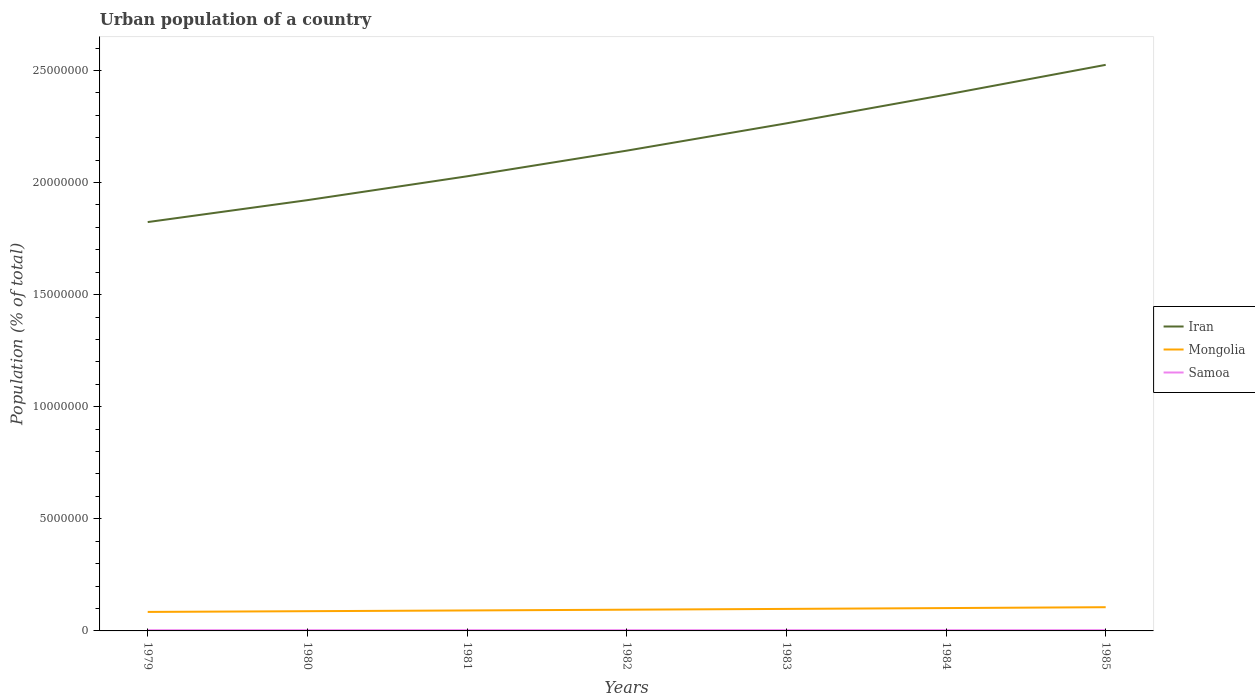How many different coloured lines are there?
Offer a terse response. 3. Across all years, what is the maximum urban population in Samoa?
Your response must be concise. 3.27e+04. In which year was the urban population in Iran maximum?
Offer a terse response. 1979. What is the total urban population in Samoa in the graph?
Your response must be concise. -632. What is the difference between the highest and the second highest urban population in Samoa?
Offer a very short reply. 1189. What is the difference between the highest and the lowest urban population in Samoa?
Keep it short and to the point. 4. Is the urban population in Samoa strictly greater than the urban population in Iran over the years?
Your answer should be compact. Yes. How many lines are there?
Ensure brevity in your answer.  3. How many years are there in the graph?
Give a very brief answer. 7. What is the difference between two consecutive major ticks on the Y-axis?
Keep it short and to the point. 5.00e+06. Does the graph contain any zero values?
Offer a terse response. No. How are the legend labels stacked?
Your answer should be compact. Vertical. What is the title of the graph?
Keep it short and to the point. Urban population of a country. Does "Aruba" appear as one of the legend labels in the graph?
Give a very brief answer. No. What is the label or title of the X-axis?
Provide a short and direct response. Years. What is the label or title of the Y-axis?
Provide a succinct answer. Population (% of total). What is the Population (% of total) in Iran in 1979?
Give a very brief answer. 1.82e+07. What is the Population (% of total) of Mongolia in 1979?
Make the answer very short. 8.48e+05. What is the Population (% of total) in Samoa in 1979?
Offer a very short reply. 3.27e+04. What is the Population (% of total) of Iran in 1980?
Ensure brevity in your answer.  1.92e+07. What is the Population (% of total) in Mongolia in 1980?
Your response must be concise. 8.80e+05. What is the Population (% of total) of Samoa in 1980?
Provide a short and direct response. 3.29e+04. What is the Population (% of total) of Iran in 1981?
Your answer should be compact. 2.03e+07. What is the Population (% of total) of Mongolia in 1981?
Your response must be concise. 9.13e+05. What is the Population (% of total) in Samoa in 1981?
Your answer should be compact. 3.32e+04. What is the Population (% of total) of Iran in 1982?
Ensure brevity in your answer.  2.14e+07. What is the Population (% of total) in Mongolia in 1982?
Provide a succinct answer. 9.47e+05. What is the Population (% of total) of Samoa in 1982?
Ensure brevity in your answer.  3.34e+04. What is the Population (% of total) of Iran in 1983?
Your answer should be very brief. 2.26e+07. What is the Population (% of total) of Mongolia in 1983?
Offer a terse response. 9.82e+05. What is the Population (% of total) of Samoa in 1983?
Your answer should be very brief. 3.36e+04. What is the Population (% of total) in Iran in 1984?
Give a very brief answer. 2.39e+07. What is the Population (% of total) of Mongolia in 1984?
Keep it short and to the point. 1.02e+06. What is the Population (% of total) of Samoa in 1984?
Your answer should be very brief. 3.38e+04. What is the Population (% of total) of Iran in 1985?
Your response must be concise. 2.53e+07. What is the Population (% of total) of Mongolia in 1985?
Give a very brief answer. 1.06e+06. What is the Population (% of total) in Samoa in 1985?
Your answer should be very brief. 3.39e+04. Across all years, what is the maximum Population (% of total) in Iran?
Offer a very short reply. 2.53e+07. Across all years, what is the maximum Population (% of total) of Mongolia?
Provide a succinct answer. 1.06e+06. Across all years, what is the maximum Population (% of total) in Samoa?
Ensure brevity in your answer.  3.39e+04. Across all years, what is the minimum Population (% of total) of Iran?
Offer a very short reply. 1.82e+07. Across all years, what is the minimum Population (% of total) of Mongolia?
Offer a very short reply. 8.48e+05. Across all years, what is the minimum Population (% of total) of Samoa?
Provide a succinct answer. 3.27e+04. What is the total Population (% of total) of Iran in the graph?
Ensure brevity in your answer.  1.51e+08. What is the total Population (% of total) of Mongolia in the graph?
Your answer should be very brief. 6.65e+06. What is the total Population (% of total) in Samoa in the graph?
Provide a short and direct response. 2.33e+05. What is the difference between the Population (% of total) in Iran in 1979 and that in 1980?
Make the answer very short. -9.78e+05. What is the difference between the Population (% of total) of Mongolia in 1979 and that in 1980?
Provide a succinct answer. -3.24e+04. What is the difference between the Population (% of total) in Samoa in 1979 and that in 1980?
Your response must be concise. -198. What is the difference between the Population (% of total) of Iran in 1979 and that in 1981?
Make the answer very short. -2.04e+06. What is the difference between the Population (% of total) of Mongolia in 1979 and that in 1981?
Offer a very short reply. -6.55e+04. What is the difference between the Population (% of total) of Samoa in 1979 and that in 1981?
Provide a succinct answer. -416. What is the difference between the Population (% of total) of Iran in 1979 and that in 1982?
Give a very brief answer. -3.19e+06. What is the difference between the Population (% of total) of Mongolia in 1979 and that in 1982?
Offer a very short reply. -9.93e+04. What is the difference between the Population (% of total) of Samoa in 1979 and that in 1982?
Your answer should be very brief. -632. What is the difference between the Population (% of total) of Iran in 1979 and that in 1983?
Provide a succinct answer. -4.40e+06. What is the difference between the Population (% of total) in Mongolia in 1979 and that in 1983?
Provide a succinct answer. -1.34e+05. What is the difference between the Population (% of total) of Samoa in 1979 and that in 1983?
Your answer should be very brief. -840. What is the difference between the Population (% of total) in Iran in 1979 and that in 1984?
Give a very brief answer. -5.68e+06. What is the difference between the Population (% of total) in Mongolia in 1979 and that in 1984?
Provide a succinct answer. -1.71e+05. What is the difference between the Population (% of total) in Samoa in 1979 and that in 1984?
Offer a very short reply. -1031. What is the difference between the Population (% of total) in Iran in 1979 and that in 1985?
Your answer should be very brief. -7.01e+06. What is the difference between the Population (% of total) in Mongolia in 1979 and that in 1985?
Offer a very short reply. -2.10e+05. What is the difference between the Population (% of total) of Samoa in 1979 and that in 1985?
Provide a short and direct response. -1189. What is the difference between the Population (% of total) of Iran in 1980 and that in 1981?
Offer a very short reply. -1.06e+06. What is the difference between the Population (% of total) of Mongolia in 1980 and that in 1981?
Make the answer very short. -3.31e+04. What is the difference between the Population (% of total) in Samoa in 1980 and that in 1981?
Make the answer very short. -218. What is the difference between the Population (% of total) of Iran in 1980 and that in 1982?
Provide a short and direct response. -2.21e+06. What is the difference between the Population (% of total) in Mongolia in 1980 and that in 1982?
Provide a short and direct response. -6.70e+04. What is the difference between the Population (% of total) of Samoa in 1980 and that in 1982?
Provide a succinct answer. -434. What is the difference between the Population (% of total) in Iran in 1980 and that in 1983?
Offer a terse response. -3.43e+06. What is the difference between the Population (% of total) in Mongolia in 1980 and that in 1983?
Provide a succinct answer. -1.02e+05. What is the difference between the Population (% of total) in Samoa in 1980 and that in 1983?
Your response must be concise. -642. What is the difference between the Population (% of total) in Iran in 1980 and that in 1984?
Your answer should be compact. -4.71e+06. What is the difference between the Population (% of total) in Mongolia in 1980 and that in 1984?
Provide a short and direct response. -1.39e+05. What is the difference between the Population (% of total) of Samoa in 1980 and that in 1984?
Keep it short and to the point. -833. What is the difference between the Population (% of total) of Iran in 1980 and that in 1985?
Offer a terse response. -6.04e+06. What is the difference between the Population (% of total) in Mongolia in 1980 and that in 1985?
Your answer should be very brief. -1.78e+05. What is the difference between the Population (% of total) of Samoa in 1980 and that in 1985?
Your answer should be compact. -991. What is the difference between the Population (% of total) of Iran in 1981 and that in 1982?
Your answer should be compact. -1.14e+06. What is the difference between the Population (% of total) in Mongolia in 1981 and that in 1982?
Give a very brief answer. -3.38e+04. What is the difference between the Population (% of total) in Samoa in 1981 and that in 1982?
Give a very brief answer. -216. What is the difference between the Population (% of total) in Iran in 1981 and that in 1983?
Your response must be concise. -2.36e+06. What is the difference between the Population (% of total) in Mongolia in 1981 and that in 1983?
Your answer should be very brief. -6.89e+04. What is the difference between the Population (% of total) in Samoa in 1981 and that in 1983?
Make the answer very short. -424. What is the difference between the Population (% of total) in Iran in 1981 and that in 1984?
Ensure brevity in your answer.  -3.64e+06. What is the difference between the Population (% of total) of Mongolia in 1981 and that in 1984?
Give a very brief answer. -1.06e+05. What is the difference between the Population (% of total) of Samoa in 1981 and that in 1984?
Offer a very short reply. -615. What is the difference between the Population (% of total) in Iran in 1981 and that in 1985?
Your answer should be very brief. -4.97e+06. What is the difference between the Population (% of total) in Mongolia in 1981 and that in 1985?
Make the answer very short. -1.45e+05. What is the difference between the Population (% of total) in Samoa in 1981 and that in 1985?
Provide a short and direct response. -773. What is the difference between the Population (% of total) in Iran in 1982 and that in 1983?
Offer a very short reply. -1.22e+06. What is the difference between the Population (% of total) of Mongolia in 1982 and that in 1983?
Ensure brevity in your answer.  -3.50e+04. What is the difference between the Population (% of total) in Samoa in 1982 and that in 1983?
Your answer should be very brief. -208. What is the difference between the Population (% of total) in Iran in 1982 and that in 1984?
Your response must be concise. -2.50e+06. What is the difference between the Population (% of total) of Mongolia in 1982 and that in 1984?
Provide a short and direct response. -7.19e+04. What is the difference between the Population (% of total) of Samoa in 1982 and that in 1984?
Offer a terse response. -399. What is the difference between the Population (% of total) in Iran in 1982 and that in 1985?
Provide a short and direct response. -3.83e+06. What is the difference between the Population (% of total) in Mongolia in 1982 and that in 1985?
Offer a very short reply. -1.11e+05. What is the difference between the Population (% of total) in Samoa in 1982 and that in 1985?
Ensure brevity in your answer.  -557. What is the difference between the Population (% of total) of Iran in 1983 and that in 1984?
Your response must be concise. -1.28e+06. What is the difference between the Population (% of total) of Mongolia in 1983 and that in 1984?
Give a very brief answer. -3.69e+04. What is the difference between the Population (% of total) in Samoa in 1983 and that in 1984?
Ensure brevity in your answer.  -191. What is the difference between the Population (% of total) in Iran in 1983 and that in 1985?
Keep it short and to the point. -2.61e+06. What is the difference between the Population (% of total) in Mongolia in 1983 and that in 1985?
Ensure brevity in your answer.  -7.58e+04. What is the difference between the Population (% of total) of Samoa in 1983 and that in 1985?
Make the answer very short. -349. What is the difference between the Population (% of total) of Iran in 1984 and that in 1985?
Your answer should be very brief. -1.33e+06. What is the difference between the Population (% of total) in Mongolia in 1984 and that in 1985?
Provide a short and direct response. -3.90e+04. What is the difference between the Population (% of total) in Samoa in 1984 and that in 1985?
Make the answer very short. -158. What is the difference between the Population (% of total) of Iran in 1979 and the Population (% of total) of Mongolia in 1980?
Offer a very short reply. 1.74e+07. What is the difference between the Population (% of total) in Iran in 1979 and the Population (% of total) in Samoa in 1980?
Offer a terse response. 1.82e+07. What is the difference between the Population (% of total) in Mongolia in 1979 and the Population (% of total) in Samoa in 1980?
Provide a short and direct response. 8.15e+05. What is the difference between the Population (% of total) in Iran in 1979 and the Population (% of total) in Mongolia in 1981?
Your response must be concise. 1.73e+07. What is the difference between the Population (% of total) in Iran in 1979 and the Population (% of total) in Samoa in 1981?
Give a very brief answer. 1.82e+07. What is the difference between the Population (% of total) in Mongolia in 1979 and the Population (% of total) in Samoa in 1981?
Your answer should be compact. 8.14e+05. What is the difference between the Population (% of total) in Iran in 1979 and the Population (% of total) in Mongolia in 1982?
Provide a short and direct response. 1.73e+07. What is the difference between the Population (% of total) of Iran in 1979 and the Population (% of total) of Samoa in 1982?
Offer a terse response. 1.82e+07. What is the difference between the Population (% of total) of Mongolia in 1979 and the Population (% of total) of Samoa in 1982?
Make the answer very short. 8.14e+05. What is the difference between the Population (% of total) of Iran in 1979 and the Population (% of total) of Mongolia in 1983?
Provide a succinct answer. 1.73e+07. What is the difference between the Population (% of total) of Iran in 1979 and the Population (% of total) of Samoa in 1983?
Offer a very short reply. 1.82e+07. What is the difference between the Population (% of total) in Mongolia in 1979 and the Population (% of total) in Samoa in 1983?
Your response must be concise. 8.14e+05. What is the difference between the Population (% of total) in Iran in 1979 and the Population (% of total) in Mongolia in 1984?
Offer a very short reply. 1.72e+07. What is the difference between the Population (% of total) of Iran in 1979 and the Population (% of total) of Samoa in 1984?
Offer a very short reply. 1.82e+07. What is the difference between the Population (% of total) of Mongolia in 1979 and the Population (% of total) of Samoa in 1984?
Provide a succinct answer. 8.14e+05. What is the difference between the Population (% of total) of Iran in 1979 and the Population (% of total) of Mongolia in 1985?
Give a very brief answer. 1.72e+07. What is the difference between the Population (% of total) in Iran in 1979 and the Population (% of total) in Samoa in 1985?
Offer a very short reply. 1.82e+07. What is the difference between the Population (% of total) of Mongolia in 1979 and the Population (% of total) of Samoa in 1985?
Ensure brevity in your answer.  8.14e+05. What is the difference between the Population (% of total) in Iran in 1980 and the Population (% of total) in Mongolia in 1981?
Give a very brief answer. 1.83e+07. What is the difference between the Population (% of total) of Iran in 1980 and the Population (% of total) of Samoa in 1981?
Give a very brief answer. 1.92e+07. What is the difference between the Population (% of total) of Mongolia in 1980 and the Population (% of total) of Samoa in 1981?
Ensure brevity in your answer.  8.47e+05. What is the difference between the Population (% of total) of Iran in 1980 and the Population (% of total) of Mongolia in 1982?
Provide a succinct answer. 1.83e+07. What is the difference between the Population (% of total) in Iran in 1980 and the Population (% of total) in Samoa in 1982?
Give a very brief answer. 1.92e+07. What is the difference between the Population (% of total) in Mongolia in 1980 and the Population (% of total) in Samoa in 1982?
Keep it short and to the point. 8.47e+05. What is the difference between the Population (% of total) of Iran in 1980 and the Population (% of total) of Mongolia in 1983?
Your response must be concise. 1.82e+07. What is the difference between the Population (% of total) of Iran in 1980 and the Population (% of total) of Samoa in 1983?
Provide a short and direct response. 1.92e+07. What is the difference between the Population (% of total) of Mongolia in 1980 and the Population (% of total) of Samoa in 1983?
Your response must be concise. 8.46e+05. What is the difference between the Population (% of total) in Iran in 1980 and the Population (% of total) in Mongolia in 1984?
Your answer should be very brief. 1.82e+07. What is the difference between the Population (% of total) in Iran in 1980 and the Population (% of total) in Samoa in 1984?
Your response must be concise. 1.92e+07. What is the difference between the Population (% of total) in Mongolia in 1980 and the Population (% of total) in Samoa in 1984?
Your answer should be very brief. 8.46e+05. What is the difference between the Population (% of total) of Iran in 1980 and the Population (% of total) of Mongolia in 1985?
Make the answer very short. 1.82e+07. What is the difference between the Population (% of total) in Iran in 1980 and the Population (% of total) in Samoa in 1985?
Provide a short and direct response. 1.92e+07. What is the difference between the Population (% of total) in Mongolia in 1980 and the Population (% of total) in Samoa in 1985?
Give a very brief answer. 8.46e+05. What is the difference between the Population (% of total) of Iran in 1981 and the Population (% of total) of Mongolia in 1982?
Keep it short and to the point. 1.93e+07. What is the difference between the Population (% of total) of Iran in 1981 and the Population (% of total) of Samoa in 1982?
Offer a very short reply. 2.02e+07. What is the difference between the Population (% of total) in Mongolia in 1981 and the Population (% of total) in Samoa in 1982?
Your response must be concise. 8.80e+05. What is the difference between the Population (% of total) of Iran in 1981 and the Population (% of total) of Mongolia in 1983?
Keep it short and to the point. 1.93e+07. What is the difference between the Population (% of total) of Iran in 1981 and the Population (% of total) of Samoa in 1983?
Offer a very short reply. 2.02e+07. What is the difference between the Population (% of total) of Mongolia in 1981 and the Population (% of total) of Samoa in 1983?
Ensure brevity in your answer.  8.80e+05. What is the difference between the Population (% of total) of Iran in 1981 and the Population (% of total) of Mongolia in 1984?
Provide a succinct answer. 1.93e+07. What is the difference between the Population (% of total) of Iran in 1981 and the Population (% of total) of Samoa in 1984?
Keep it short and to the point. 2.02e+07. What is the difference between the Population (% of total) in Mongolia in 1981 and the Population (% of total) in Samoa in 1984?
Offer a very short reply. 8.79e+05. What is the difference between the Population (% of total) of Iran in 1981 and the Population (% of total) of Mongolia in 1985?
Your response must be concise. 1.92e+07. What is the difference between the Population (% of total) in Iran in 1981 and the Population (% of total) in Samoa in 1985?
Ensure brevity in your answer.  2.02e+07. What is the difference between the Population (% of total) in Mongolia in 1981 and the Population (% of total) in Samoa in 1985?
Your answer should be very brief. 8.79e+05. What is the difference between the Population (% of total) of Iran in 1982 and the Population (% of total) of Mongolia in 1983?
Keep it short and to the point. 2.04e+07. What is the difference between the Population (% of total) in Iran in 1982 and the Population (% of total) in Samoa in 1983?
Your answer should be compact. 2.14e+07. What is the difference between the Population (% of total) in Mongolia in 1982 and the Population (% of total) in Samoa in 1983?
Offer a very short reply. 9.13e+05. What is the difference between the Population (% of total) in Iran in 1982 and the Population (% of total) in Mongolia in 1984?
Offer a terse response. 2.04e+07. What is the difference between the Population (% of total) in Iran in 1982 and the Population (% of total) in Samoa in 1984?
Provide a short and direct response. 2.14e+07. What is the difference between the Population (% of total) in Mongolia in 1982 and the Population (% of total) in Samoa in 1984?
Offer a very short reply. 9.13e+05. What is the difference between the Population (% of total) of Iran in 1982 and the Population (% of total) of Mongolia in 1985?
Provide a short and direct response. 2.04e+07. What is the difference between the Population (% of total) of Iran in 1982 and the Population (% of total) of Samoa in 1985?
Offer a very short reply. 2.14e+07. What is the difference between the Population (% of total) in Mongolia in 1982 and the Population (% of total) in Samoa in 1985?
Provide a short and direct response. 9.13e+05. What is the difference between the Population (% of total) of Iran in 1983 and the Population (% of total) of Mongolia in 1984?
Offer a terse response. 2.16e+07. What is the difference between the Population (% of total) in Iran in 1983 and the Population (% of total) in Samoa in 1984?
Your answer should be very brief. 2.26e+07. What is the difference between the Population (% of total) in Mongolia in 1983 and the Population (% of total) in Samoa in 1984?
Provide a short and direct response. 9.48e+05. What is the difference between the Population (% of total) in Iran in 1983 and the Population (% of total) in Mongolia in 1985?
Offer a terse response. 2.16e+07. What is the difference between the Population (% of total) in Iran in 1983 and the Population (% of total) in Samoa in 1985?
Your answer should be very brief. 2.26e+07. What is the difference between the Population (% of total) of Mongolia in 1983 and the Population (% of total) of Samoa in 1985?
Your response must be concise. 9.48e+05. What is the difference between the Population (% of total) in Iran in 1984 and the Population (% of total) in Mongolia in 1985?
Give a very brief answer. 2.29e+07. What is the difference between the Population (% of total) in Iran in 1984 and the Population (% of total) in Samoa in 1985?
Give a very brief answer. 2.39e+07. What is the difference between the Population (% of total) of Mongolia in 1984 and the Population (% of total) of Samoa in 1985?
Offer a terse response. 9.85e+05. What is the average Population (% of total) of Iran per year?
Provide a short and direct response. 2.16e+07. What is the average Population (% of total) in Mongolia per year?
Offer a very short reply. 9.49e+05. What is the average Population (% of total) of Samoa per year?
Offer a terse response. 3.34e+04. In the year 1979, what is the difference between the Population (% of total) of Iran and Population (% of total) of Mongolia?
Offer a terse response. 1.74e+07. In the year 1979, what is the difference between the Population (% of total) of Iran and Population (% of total) of Samoa?
Make the answer very short. 1.82e+07. In the year 1979, what is the difference between the Population (% of total) of Mongolia and Population (% of total) of Samoa?
Keep it short and to the point. 8.15e+05. In the year 1980, what is the difference between the Population (% of total) of Iran and Population (% of total) of Mongolia?
Offer a terse response. 1.83e+07. In the year 1980, what is the difference between the Population (% of total) in Iran and Population (% of total) in Samoa?
Give a very brief answer. 1.92e+07. In the year 1980, what is the difference between the Population (% of total) of Mongolia and Population (% of total) of Samoa?
Your answer should be compact. 8.47e+05. In the year 1981, what is the difference between the Population (% of total) in Iran and Population (% of total) in Mongolia?
Your answer should be very brief. 1.94e+07. In the year 1981, what is the difference between the Population (% of total) in Iran and Population (% of total) in Samoa?
Provide a short and direct response. 2.02e+07. In the year 1981, what is the difference between the Population (% of total) of Mongolia and Population (% of total) of Samoa?
Give a very brief answer. 8.80e+05. In the year 1982, what is the difference between the Population (% of total) in Iran and Population (% of total) in Mongolia?
Your answer should be very brief. 2.05e+07. In the year 1982, what is the difference between the Population (% of total) of Iran and Population (% of total) of Samoa?
Make the answer very short. 2.14e+07. In the year 1982, what is the difference between the Population (% of total) in Mongolia and Population (% of total) in Samoa?
Give a very brief answer. 9.14e+05. In the year 1983, what is the difference between the Population (% of total) of Iran and Population (% of total) of Mongolia?
Provide a succinct answer. 2.17e+07. In the year 1983, what is the difference between the Population (% of total) of Iran and Population (% of total) of Samoa?
Provide a succinct answer. 2.26e+07. In the year 1983, what is the difference between the Population (% of total) in Mongolia and Population (% of total) in Samoa?
Ensure brevity in your answer.  9.48e+05. In the year 1984, what is the difference between the Population (% of total) of Iran and Population (% of total) of Mongolia?
Provide a succinct answer. 2.29e+07. In the year 1984, what is the difference between the Population (% of total) of Iran and Population (% of total) of Samoa?
Make the answer very short. 2.39e+07. In the year 1984, what is the difference between the Population (% of total) in Mongolia and Population (% of total) in Samoa?
Ensure brevity in your answer.  9.85e+05. In the year 1985, what is the difference between the Population (% of total) of Iran and Population (% of total) of Mongolia?
Offer a terse response. 2.42e+07. In the year 1985, what is the difference between the Population (% of total) of Iran and Population (% of total) of Samoa?
Ensure brevity in your answer.  2.52e+07. In the year 1985, what is the difference between the Population (% of total) of Mongolia and Population (% of total) of Samoa?
Offer a terse response. 1.02e+06. What is the ratio of the Population (% of total) of Iran in 1979 to that in 1980?
Make the answer very short. 0.95. What is the ratio of the Population (% of total) of Mongolia in 1979 to that in 1980?
Make the answer very short. 0.96. What is the ratio of the Population (% of total) in Iran in 1979 to that in 1981?
Offer a terse response. 0.9. What is the ratio of the Population (% of total) in Mongolia in 1979 to that in 1981?
Your answer should be compact. 0.93. What is the ratio of the Population (% of total) of Samoa in 1979 to that in 1981?
Offer a terse response. 0.99. What is the ratio of the Population (% of total) of Iran in 1979 to that in 1982?
Your answer should be compact. 0.85. What is the ratio of the Population (% of total) of Mongolia in 1979 to that in 1982?
Provide a short and direct response. 0.9. What is the ratio of the Population (% of total) in Samoa in 1979 to that in 1982?
Your answer should be compact. 0.98. What is the ratio of the Population (% of total) of Iran in 1979 to that in 1983?
Offer a terse response. 0.81. What is the ratio of the Population (% of total) of Mongolia in 1979 to that in 1983?
Keep it short and to the point. 0.86. What is the ratio of the Population (% of total) of Iran in 1979 to that in 1984?
Provide a succinct answer. 0.76. What is the ratio of the Population (% of total) in Mongolia in 1979 to that in 1984?
Offer a very short reply. 0.83. What is the ratio of the Population (% of total) in Samoa in 1979 to that in 1984?
Make the answer very short. 0.97. What is the ratio of the Population (% of total) of Iran in 1979 to that in 1985?
Provide a short and direct response. 0.72. What is the ratio of the Population (% of total) in Mongolia in 1979 to that in 1985?
Your answer should be compact. 0.8. What is the ratio of the Population (% of total) of Samoa in 1979 to that in 1985?
Your response must be concise. 0.96. What is the ratio of the Population (% of total) of Iran in 1980 to that in 1981?
Offer a very short reply. 0.95. What is the ratio of the Population (% of total) of Mongolia in 1980 to that in 1981?
Your answer should be compact. 0.96. What is the ratio of the Population (% of total) in Samoa in 1980 to that in 1981?
Offer a very short reply. 0.99. What is the ratio of the Population (% of total) of Iran in 1980 to that in 1982?
Ensure brevity in your answer.  0.9. What is the ratio of the Population (% of total) in Mongolia in 1980 to that in 1982?
Offer a terse response. 0.93. What is the ratio of the Population (% of total) of Iran in 1980 to that in 1983?
Give a very brief answer. 0.85. What is the ratio of the Population (% of total) in Mongolia in 1980 to that in 1983?
Give a very brief answer. 0.9. What is the ratio of the Population (% of total) in Samoa in 1980 to that in 1983?
Ensure brevity in your answer.  0.98. What is the ratio of the Population (% of total) in Iran in 1980 to that in 1984?
Give a very brief answer. 0.8. What is the ratio of the Population (% of total) in Mongolia in 1980 to that in 1984?
Your response must be concise. 0.86. What is the ratio of the Population (% of total) of Samoa in 1980 to that in 1984?
Give a very brief answer. 0.98. What is the ratio of the Population (% of total) of Iran in 1980 to that in 1985?
Ensure brevity in your answer.  0.76. What is the ratio of the Population (% of total) in Mongolia in 1980 to that in 1985?
Make the answer very short. 0.83. What is the ratio of the Population (% of total) in Samoa in 1980 to that in 1985?
Your answer should be very brief. 0.97. What is the ratio of the Population (% of total) of Iran in 1981 to that in 1982?
Make the answer very short. 0.95. What is the ratio of the Population (% of total) of Samoa in 1981 to that in 1982?
Your answer should be compact. 0.99. What is the ratio of the Population (% of total) in Iran in 1981 to that in 1983?
Provide a short and direct response. 0.9. What is the ratio of the Population (% of total) of Mongolia in 1981 to that in 1983?
Keep it short and to the point. 0.93. What is the ratio of the Population (% of total) of Samoa in 1981 to that in 1983?
Your answer should be very brief. 0.99. What is the ratio of the Population (% of total) in Iran in 1981 to that in 1984?
Your response must be concise. 0.85. What is the ratio of the Population (% of total) in Mongolia in 1981 to that in 1984?
Ensure brevity in your answer.  0.9. What is the ratio of the Population (% of total) of Samoa in 1981 to that in 1984?
Your answer should be compact. 0.98. What is the ratio of the Population (% of total) in Iran in 1981 to that in 1985?
Offer a terse response. 0.8. What is the ratio of the Population (% of total) in Mongolia in 1981 to that in 1985?
Ensure brevity in your answer.  0.86. What is the ratio of the Population (% of total) in Samoa in 1981 to that in 1985?
Provide a short and direct response. 0.98. What is the ratio of the Population (% of total) in Iran in 1982 to that in 1983?
Offer a terse response. 0.95. What is the ratio of the Population (% of total) in Iran in 1982 to that in 1984?
Provide a short and direct response. 0.9. What is the ratio of the Population (% of total) in Mongolia in 1982 to that in 1984?
Offer a very short reply. 0.93. What is the ratio of the Population (% of total) in Samoa in 1982 to that in 1984?
Offer a very short reply. 0.99. What is the ratio of the Population (% of total) of Iran in 1982 to that in 1985?
Your answer should be compact. 0.85. What is the ratio of the Population (% of total) in Mongolia in 1982 to that in 1985?
Keep it short and to the point. 0.9. What is the ratio of the Population (% of total) in Samoa in 1982 to that in 1985?
Provide a short and direct response. 0.98. What is the ratio of the Population (% of total) of Iran in 1983 to that in 1984?
Ensure brevity in your answer.  0.95. What is the ratio of the Population (% of total) of Mongolia in 1983 to that in 1984?
Ensure brevity in your answer.  0.96. What is the ratio of the Population (% of total) of Samoa in 1983 to that in 1984?
Give a very brief answer. 0.99. What is the ratio of the Population (% of total) of Iran in 1983 to that in 1985?
Give a very brief answer. 0.9. What is the ratio of the Population (% of total) in Mongolia in 1983 to that in 1985?
Provide a short and direct response. 0.93. What is the ratio of the Population (% of total) of Samoa in 1983 to that in 1985?
Your answer should be very brief. 0.99. What is the ratio of the Population (% of total) of Mongolia in 1984 to that in 1985?
Your answer should be compact. 0.96. What is the ratio of the Population (% of total) in Samoa in 1984 to that in 1985?
Your answer should be compact. 1. What is the difference between the highest and the second highest Population (% of total) in Iran?
Your answer should be very brief. 1.33e+06. What is the difference between the highest and the second highest Population (% of total) in Mongolia?
Make the answer very short. 3.90e+04. What is the difference between the highest and the second highest Population (% of total) of Samoa?
Provide a short and direct response. 158. What is the difference between the highest and the lowest Population (% of total) in Iran?
Provide a succinct answer. 7.01e+06. What is the difference between the highest and the lowest Population (% of total) in Mongolia?
Your answer should be compact. 2.10e+05. What is the difference between the highest and the lowest Population (% of total) of Samoa?
Your answer should be compact. 1189. 